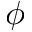<formula> <loc_0><loc_0><loc_500><loc_500>\phi</formula> 